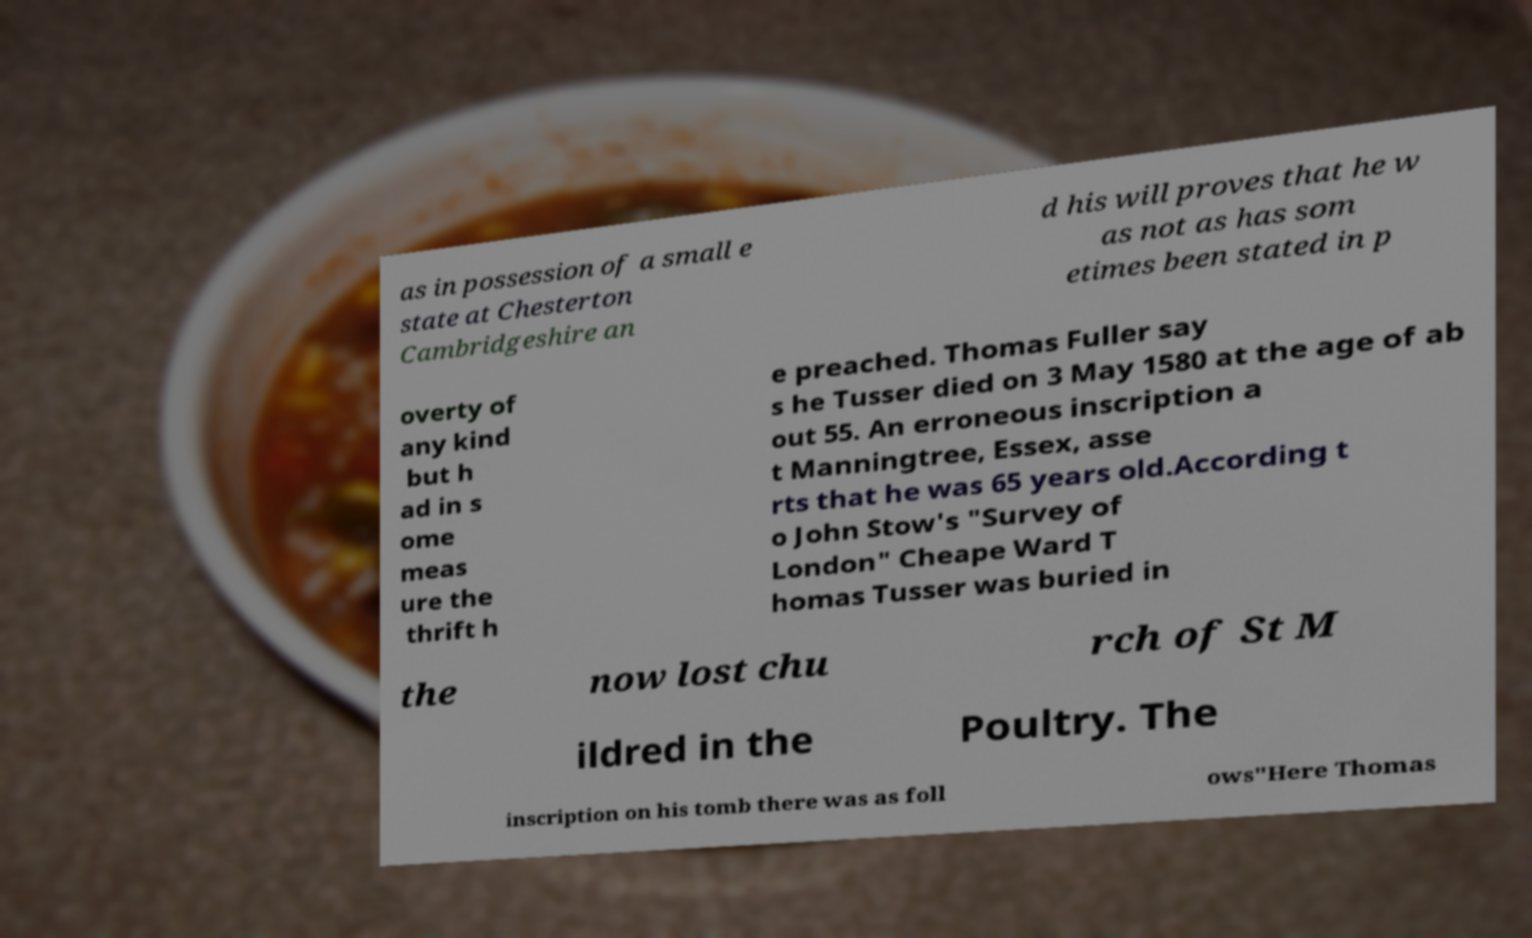Please read and relay the text visible in this image. What does it say? as in possession of a small e state at Chesterton Cambridgeshire an d his will proves that he w as not as has som etimes been stated in p overty of any kind but h ad in s ome meas ure the thrift h e preached. Thomas Fuller say s he Tusser died on 3 May 1580 at the age of ab out 55. An erroneous inscription a t Manningtree, Essex, asse rts that he was 65 years old.According t o John Stow's "Survey of London" Cheape Ward T homas Tusser was buried in the now lost chu rch of St M ildred in the Poultry. The inscription on his tomb there was as foll ows"Here Thomas 